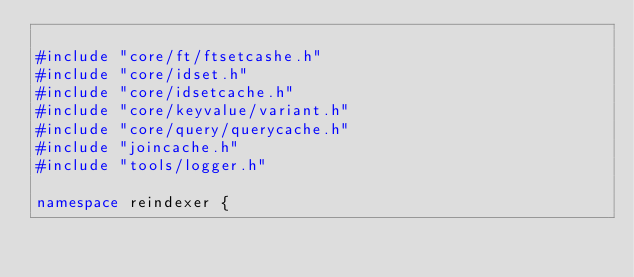<code> <loc_0><loc_0><loc_500><loc_500><_C++_>
#include "core/ft/ftsetcashe.h"
#include "core/idset.h"
#include "core/idsetcache.h"
#include "core/keyvalue/variant.h"
#include "core/query/querycache.h"
#include "joincache.h"
#include "tools/logger.h"

namespace reindexer {
</code> 